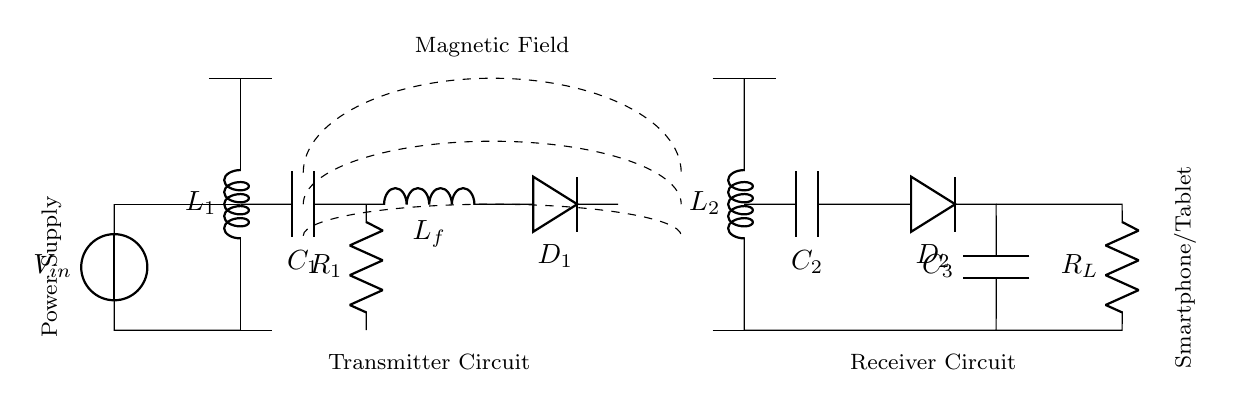What are the main components in this circuit? The circuit includes a power source, two inductors, two capacitors, two diodes, and a resistor. These components work together to create a wireless charging system.
Answer: Power source, two inductors, two capacitors, two diodes, resistor What is the purpose of the transmitters in the circuit? The transmitter inductance, represented by L1 and associated components, generates a magnetic field that transfers energy wirelessly to the receiver circuit, which utilizes the magnetic field to power devices.
Answer: Generate a magnetic field How many capacitors are there in the receiver circuit? There are two capacitors labeled C2 and C3 in the receiver circuit, which are used for smoothing and filtering the rectified voltage output.
Answer: Two What is the role of D1 and D2 in the circuit? Both diodes D1 and D2 serve as rectifiers; they convert the alternating current induced in the receiver coil into direct current suitable for charging the device.
Answer: Rectification How does the current flow from the power source to the smartphone/tablet? The current flows from the power source through the transmitter circuit, inducing a magnetic field around the transmitter coil, which then transfers energy to the receiver coil. The receiver circuit rectifies this energy, allowing it to charge the connected device.
Answer: Through the transmitter, induced magnetic field, receiver, and rectification 